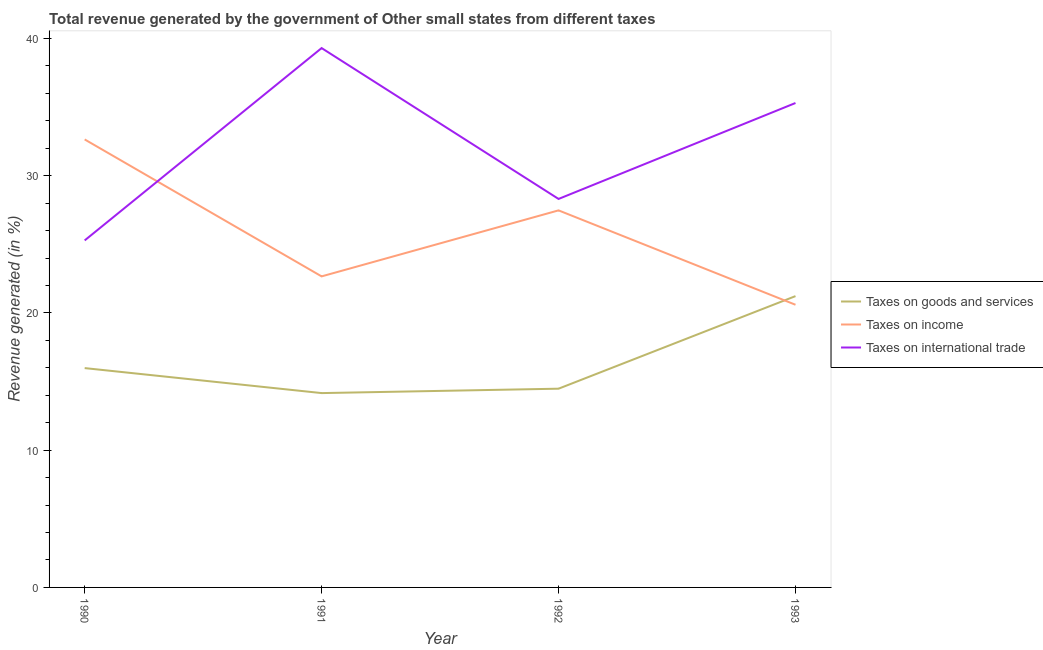How many different coloured lines are there?
Give a very brief answer. 3. Is the number of lines equal to the number of legend labels?
Keep it short and to the point. Yes. What is the percentage of revenue generated by tax on international trade in 1990?
Give a very brief answer. 25.29. Across all years, what is the maximum percentage of revenue generated by taxes on income?
Keep it short and to the point. 32.64. Across all years, what is the minimum percentage of revenue generated by tax on international trade?
Give a very brief answer. 25.29. In which year was the percentage of revenue generated by taxes on goods and services minimum?
Give a very brief answer. 1991. What is the total percentage of revenue generated by tax on international trade in the graph?
Your response must be concise. 128.19. What is the difference between the percentage of revenue generated by taxes on goods and services in 1990 and that in 1992?
Ensure brevity in your answer.  1.5. What is the difference between the percentage of revenue generated by taxes on goods and services in 1990 and the percentage of revenue generated by tax on international trade in 1993?
Your answer should be compact. -19.32. What is the average percentage of revenue generated by tax on international trade per year?
Make the answer very short. 32.05. In the year 1991, what is the difference between the percentage of revenue generated by taxes on income and percentage of revenue generated by tax on international trade?
Give a very brief answer. -16.64. What is the ratio of the percentage of revenue generated by taxes on goods and services in 1992 to that in 1993?
Offer a terse response. 0.68. Is the percentage of revenue generated by tax on international trade in 1990 less than that in 1993?
Your response must be concise. Yes. What is the difference between the highest and the second highest percentage of revenue generated by taxes on income?
Provide a succinct answer. 5.17. What is the difference between the highest and the lowest percentage of revenue generated by taxes on goods and services?
Ensure brevity in your answer.  7.07. Is the sum of the percentage of revenue generated by taxes on goods and services in 1990 and 1992 greater than the maximum percentage of revenue generated by taxes on income across all years?
Give a very brief answer. No. Does the percentage of revenue generated by taxes on income monotonically increase over the years?
Offer a terse response. No. Is the percentage of revenue generated by taxes on goods and services strictly less than the percentage of revenue generated by tax on international trade over the years?
Offer a very short reply. Yes. How many lines are there?
Make the answer very short. 3. How many years are there in the graph?
Keep it short and to the point. 4. What is the difference between two consecutive major ticks on the Y-axis?
Your answer should be compact. 10. Does the graph contain any zero values?
Your answer should be very brief. No. Where does the legend appear in the graph?
Make the answer very short. Center right. How many legend labels are there?
Your answer should be very brief. 3. What is the title of the graph?
Your response must be concise. Total revenue generated by the government of Other small states from different taxes. What is the label or title of the X-axis?
Keep it short and to the point. Year. What is the label or title of the Y-axis?
Your answer should be compact. Revenue generated (in %). What is the Revenue generated (in %) of Taxes on goods and services in 1990?
Give a very brief answer. 15.98. What is the Revenue generated (in %) in Taxes on income in 1990?
Keep it short and to the point. 32.64. What is the Revenue generated (in %) of Taxes on international trade in 1990?
Give a very brief answer. 25.29. What is the Revenue generated (in %) of Taxes on goods and services in 1991?
Provide a short and direct response. 14.16. What is the Revenue generated (in %) in Taxes on income in 1991?
Your answer should be compact. 22.66. What is the Revenue generated (in %) of Taxes on international trade in 1991?
Provide a succinct answer. 39.3. What is the Revenue generated (in %) of Taxes on goods and services in 1992?
Offer a very short reply. 14.48. What is the Revenue generated (in %) in Taxes on income in 1992?
Provide a succinct answer. 27.47. What is the Revenue generated (in %) in Taxes on international trade in 1992?
Provide a succinct answer. 28.31. What is the Revenue generated (in %) in Taxes on goods and services in 1993?
Your answer should be very brief. 21.23. What is the Revenue generated (in %) in Taxes on income in 1993?
Ensure brevity in your answer.  20.6. What is the Revenue generated (in %) in Taxes on international trade in 1993?
Offer a very short reply. 35.3. Across all years, what is the maximum Revenue generated (in %) in Taxes on goods and services?
Your answer should be compact. 21.23. Across all years, what is the maximum Revenue generated (in %) in Taxes on income?
Ensure brevity in your answer.  32.64. Across all years, what is the maximum Revenue generated (in %) of Taxes on international trade?
Your answer should be very brief. 39.3. Across all years, what is the minimum Revenue generated (in %) in Taxes on goods and services?
Your response must be concise. 14.16. Across all years, what is the minimum Revenue generated (in %) of Taxes on income?
Provide a short and direct response. 20.6. Across all years, what is the minimum Revenue generated (in %) in Taxes on international trade?
Ensure brevity in your answer.  25.29. What is the total Revenue generated (in %) in Taxes on goods and services in the graph?
Ensure brevity in your answer.  65.85. What is the total Revenue generated (in %) in Taxes on income in the graph?
Ensure brevity in your answer.  103.38. What is the total Revenue generated (in %) in Taxes on international trade in the graph?
Give a very brief answer. 128.19. What is the difference between the Revenue generated (in %) in Taxes on goods and services in 1990 and that in 1991?
Give a very brief answer. 1.82. What is the difference between the Revenue generated (in %) of Taxes on income in 1990 and that in 1991?
Provide a short and direct response. 9.98. What is the difference between the Revenue generated (in %) in Taxes on international trade in 1990 and that in 1991?
Offer a terse response. -14.02. What is the difference between the Revenue generated (in %) in Taxes on goods and services in 1990 and that in 1992?
Your answer should be very brief. 1.5. What is the difference between the Revenue generated (in %) of Taxes on income in 1990 and that in 1992?
Your response must be concise. 5.17. What is the difference between the Revenue generated (in %) of Taxes on international trade in 1990 and that in 1992?
Provide a succinct answer. -3.02. What is the difference between the Revenue generated (in %) in Taxes on goods and services in 1990 and that in 1993?
Ensure brevity in your answer.  -5.24. What is the difference between the Revenue generated (in %) of Taxes on income in 1990 and that in 1993?
Make the answer very short. 12.05. What is the difference between the Revenue generated (in %) in Taxes on international trade in 1990 and that in 1993?
Provide a short and direct response. -10.01. What is the difference between the Revenue generated (in %) of Taxes on goods and services in 1991 and that in 1992?
Your answer should be compact. -0.32. What is the difference between the Revenue generated (in %) of Taxes on income in 1991 and that in 1992?
Make the answer very short. -4.81. What is the difference between the Revenue generated (in %) of Taxes on international trade in 1991 and that in 1992?
Your answer should be very brief. 10.99. What is the difference between the Revenue generated (in %) of Taxes on goods and services in 1991 and that in 1993?
Keep it short and to the point. -7.07. What is the difference between the Revenue generated (in %) in Taxes on income in 1991 and that in 1993?
Ensure brevity in your answer.  2.07. What is the difference between the Revenue generated (in %) in Taxes on international trade in 1991 and that in 1993?
Your response must be concise. 4. What is the difference between the Revenue generated (in %) in Taxes on goods and services in 1992 and that in 1993?
Your answer should be compact. -6.75. What is the difference between the Revenue generated (in %) of Taxes on income in 1992 and that in 1993?
Ensure brevity in your answer.  6.88. What is the difference between the Revenue generated (in %) in Taxes on international trade in 1992 and that in 1993?
Provide a short and direct response. -6.99. What is the difference between the Revenue generated (in %) of Taxes on goods and services in 1990 and the Revenue generated (in %) of Taxes on income in 1991?
Keep it short and to the point. -6.68. What is the difference between the Revenue generated (in %) of Taxes on goods and services in 1990 and the Revenue generated (in %) of Taxes on international trade in 1991?
Provide a succinct answer. -23.32. What is the difference between the Revenue generated (in %) of Taxes on income in 1990 and the Revenue generated (in %) of Taxes on international trade in 1991?
Ensure brevity in your answer.  -6.66. What is the difference between the Revenue generated (in %) in Taxes on goods and services in 1990 and the Revenue generated (in %) in Taxes on income in 1992?
Make the answer very short. -11.49. What is the difference between the Revenue generated (in %) of Taxes on goods and services in 1990 and the Revenue generated (in %) of Taxes on international trade in 1992?
Your answer should be very brief. -12.33. What is the difference between the Revenue generated (in %) of Taxes on income in 1990 and the Revenue generated (in %) of Taxes on international trade in 1992?
Your response must be concise. 4.34. What is the difference between the Revenue generated (in %) of Taxes on goods and services in 1990 and the Revenue generated (in %) of Taxes on income in 1993?
Your answer should be compact. -4.62. What is the difference between the Revenue generated (in %) of Taxes on goods and services in 1990 and the Revenue generated (in %) of Taxes on international trade in 1993?
Provide a succinct answer. -19.32. What is the difference between the Revenue generated (in %) in Taxes on income in 1990 and the Revenue generated (in %) in Taxes on international trade in 1993?
Offer a terse response. -2.65. What is the difference between the Revenue generated (in %) in Taxes on goods and services in 1991 and the Revenue generated (in %) in Taxes on income in 1992?
Provide a short and direct response. -13.31. What is the difference between the Revenue generated (in %) of Taxes on goods and services in 1991 and the Revenue generated (in %) of Taxes on international trade in 1992?
Your response must be concise. -14.15. What is the difference between the Revenue generated (in %) in Taxes on income in 1991 and the Revenue generated (in %) in Taxes on international trade in 1992?
Offer a very short reply. -5.64. What is the difference between the Revenue generated (in %) in Taxes on goods and services in 1991 and the Revenue generated (in %) in Taxes on income in 1993?
Offer a very short reply. -6.44. What is the difference between the Revenue generated (in %) in Taxes on goods and services in 1991 and the Revenue generated (in %) in Taxes on international trade in 1993?
Your answer should be compact. -21.14. What is the difference between the Revenue generated (in %) of Taxes on income in 1991 and the Revenue generated (in %) of Taxes on international trade in 1993?
Keep it short and to the point. -12.63. What is the difference between the Revenue generated (in %) in Taxes on goods and services in 1992 and the Revenue generated (in %) in Taxes on income in 1993?
Offer a terse response. -6.12. What is the difference between the Revenue generated (in %) of Taxes on goods and services in 1992 and the Revenue generated (in %) of Taxes on international trade in 1993?
Your response must be concise. -20.82. What is the difference between the Revenue generated (in %) in Taxes on income in 1992 and the Revenue generated (in %) in Taxes on international trade in 1993?
Make the answer very short. -7.82. What is the average Revenue generated (in %) of Taxes on goods and services per year?
Give a very brief answer. 16.46. What is the average Revenue generated (in %) in Taxes on income per year?
Your response must be concise. 25.85. What is the average Revenue generated (in %) in Taxes on international trade per year?
Make the answer very short. 32.05. In the year 1990, what is the difference between the Revenue generated (in %) in Taxes on goods and services and Revenue generated (in %) in Taxes on income?
Your answer should be very brief. -16.66. In the year 1990, what is the difference between the Revenue generated (in %) of Taxes on goods and services and Revenue generated (in %) of Taxes on international trade?
Provide a succinct answer. -9.3. In the year 1990, what is the difference between the Revenue generated (in %) in Taxes on income and Revenue generated (in %) in Taxes on international trade?
Give a very brief answer. 7.36. In the year 1991, what is the difference between the Revenue generated (in %) of Taxes on goods and services and Revenue generated (in %) of Taxes on income?
Offer a terse response. -8.5. In the year 1991, what is the difference between the Revenue generated (in %) in Taxes on goods and services and Revenue generated (in %) in Taxes on international trade?
Provide a succinct answer. -25.14. In the year 1991, what is the difference between the Revenue generated (in %) in Taxes on income and Revenue generated (in %) in Taxes on international trade?
Provide a short and direct response. -16.64. In the year 1992, what is the difference between the Revenue generated (in %) in Taxes on goods and services and Revenue generated (in %) in Taxes on income?
Your response must be concise. -12.99. In the year 1992, what is the difference between the Revenue generated (in %) of Taxes on goods and services and Revenue generated (in %) of Taxes on international trade?
Your answer should be compact. -13.83. In the year 1992, what is the difference between the Revenue generated (in %) in Taxes on income and Revenue generated (in %) in Taxes on international trade?
Keep it short and to the point. -0.83. In the year 1993, what is the difference between the Revenue generated (in %) of Taxes on goods and services and Revenue generated (in %) of Taxes on income?
Provide a short and direct response. 0.63. In the year 1993, what is the difference between the Revenue generated (in %) in Taxes on goods and services and Revenue generated (in %) in Taxes on international trade?
Offer a very short reply. -14.07. In the year 1993, what is the difference between the Revenue generated (in %) in Taxes on income and Revenue generated (in %) in Taxes on international trade?
Provide a short and direct response. -14.7. What is the ratio of the Revenue generated (in %) in Taxes on goods and services in 1990 to that in 1991?
Provide a succinct answer. 1.13. What is the ratio of the Revenue generated (in %) in Taxes on income in 1990 to that in 1991?
Ensure brevity in your answer.  1.44. What is the ratio of the Revenue generated (in %) of Taxes on international trade in 1990 to that in 1991?
Keep it short and to the point. 0.64. What is the ratio of the Revenue generated (in %) in Taxes on goods and services in 1990 to that in 1992?
Offer a terse response. 1.1. What is the ratio of the Revenue generated (in %) in Taxes on income in 1990 to that in 1992?
Offer a very short reply. 1.19. What is the ratio of the Revenue generated (in %) of Taxes on international trade in 1990 to that in 1992?
Offer a very short reply. 0.89. What is the ratio of the Revenue generated (in %) in Taxes on goods and services in 1990 to that in 1993?
Provide a short and direct response. 0.75. What is the ratio of the Revenue generated (in %) in Taxes on income in 1990 to that in 1993?
Ensure brevity in your answer.  1.58. What is the ratio of the Revenue generated (in %) of Taxes on international trade in 1990 to that in 1993?
Make the answer very short. 0.72. What is the ratio of the Revenue generated (in %) in Taxes on goods and services in 1991 to that in 1992?
Provide a succinct answer. 0.98. What is the ratio of the Revenue generated (in %) in Taxes on income in 1991 to that in 1992?
Offer a very short reply. 0.82. What is the ratio of the Revenue generated (in %) in Taxes on international trade in 1991 to that in 1992?
Make the answer very short. 1.39. What is the ratio of the Revenue generated (in %) in Taxes on goods and services in 1991 to that in 1993?
Provide a short and direct response. 0.67. What is the ratio of the Revenue generated (in %) of Taxes on income in 1991 to that in 1993?
Keep it short and to the point. 1.1. What is the ratio of the Revenue generated (in %) of Taxes on international trade in 1991 to that in 1993?
Ensure brevity in your answer.  1.11. What is the ratio of the Revenue generated (in %) in Taxes on goods and services in 1992 to that in 1993?
Make the answer very short. 0.68. What is the ratio of the Revenue generated (in %) of Taxes on income in 1992 to that in 1993?
Your response must be concise. 1.33. What is the ratio of the Revenue generated (in %) of Taxes on international trade in 1992 to that in 1993?
Ensure brevity in your answer.  0.8. What is the difference between the highest and the second highest Revenue generated (in %) of Taxes on goods and services?
Provide a succinct answer. 5.24. What is the difference between the highest and the second highest Revenue generated (in %) in Taxes on income?
Offer a terse response. 5.17. What is the difference between the highest and the second highest Revenue generated (in %) in Taxes on international trade?
Your response must be concise. 4. What is the difference between the highest and the lowest Revenue generated (in %) in Taxes on goods and services?
Provide a succinct answer. 7.07. What is the difference between the highest and the lowest Revenue generated (in %) in Taxes on income?
Your answer should be compact. 12.05. What is the difference between the highest and the lowest Revenue generated (in %) in Taxes on international trade?
Your answer should be very brief. 14.02. 